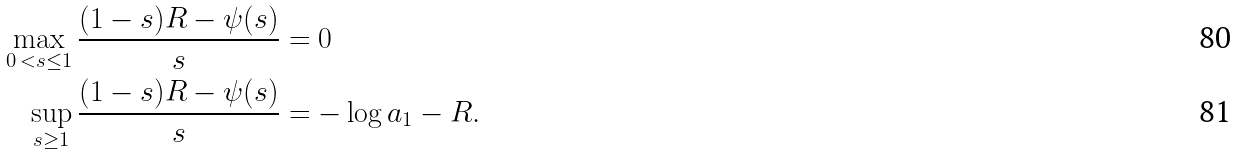<formula> <loc_0><loc_0><loc_500><loc_500>\max _ { 0 \, < s \leq 1 } \frac { ( 1 - s ) R - \psi ( s ) } { s } & = 0 \\ \sup _ { s \geq 1 } \frac { ( 1 - s ) R - \psi ( s ) } { s } & = - \log a _ { 1 } - R .</formula> 